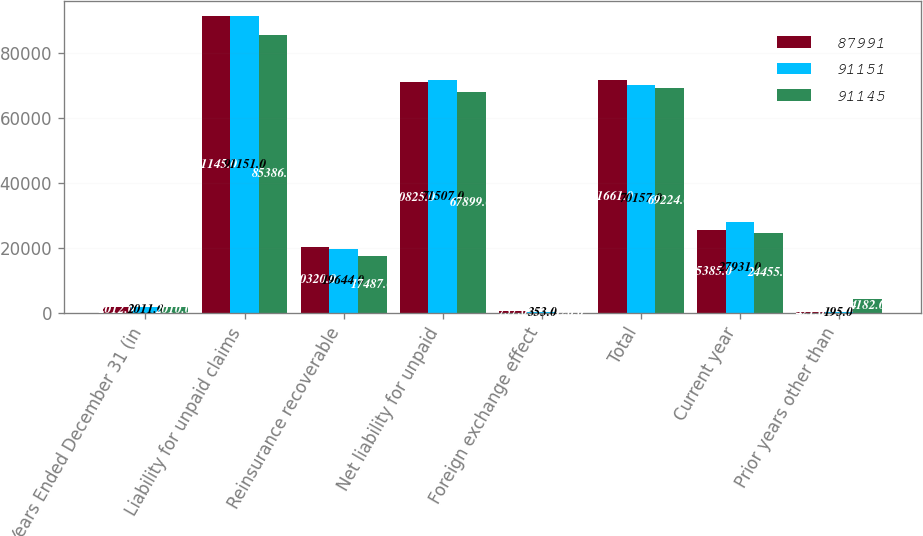Convert chart. <chart><loc_0><loc_0><loc_500><loc_500><stacked_bar_chart><ecel><fcel>Years Ended December 31 (in<fcel>Liability for unpaid claims<fcel>Reinsurance recoverable<fcel>Net liability for unpaid<fcel>Foreign exchange effect<fcel>Total<fcel>Current year<fcel>Prior years other than<nl><fcel>87991<fcel>2012<fcel>91145<fcel>20320<fcel>70825<fcel>757<fcel>71661<fcel>25385<fcel>421<nl><fcel>91151<fcel>2011<fcel>91151<fcel>19644<fcel>71507<fcel>353<fcel>70157<fcel>27931<fcel>195<nl><fcel>91145<fcel>2010<fcel>85386<fcel>17487<fcel>67899<fcel>126<fcel>69224<fcel>24455<fcel>4182<nl></chart> 